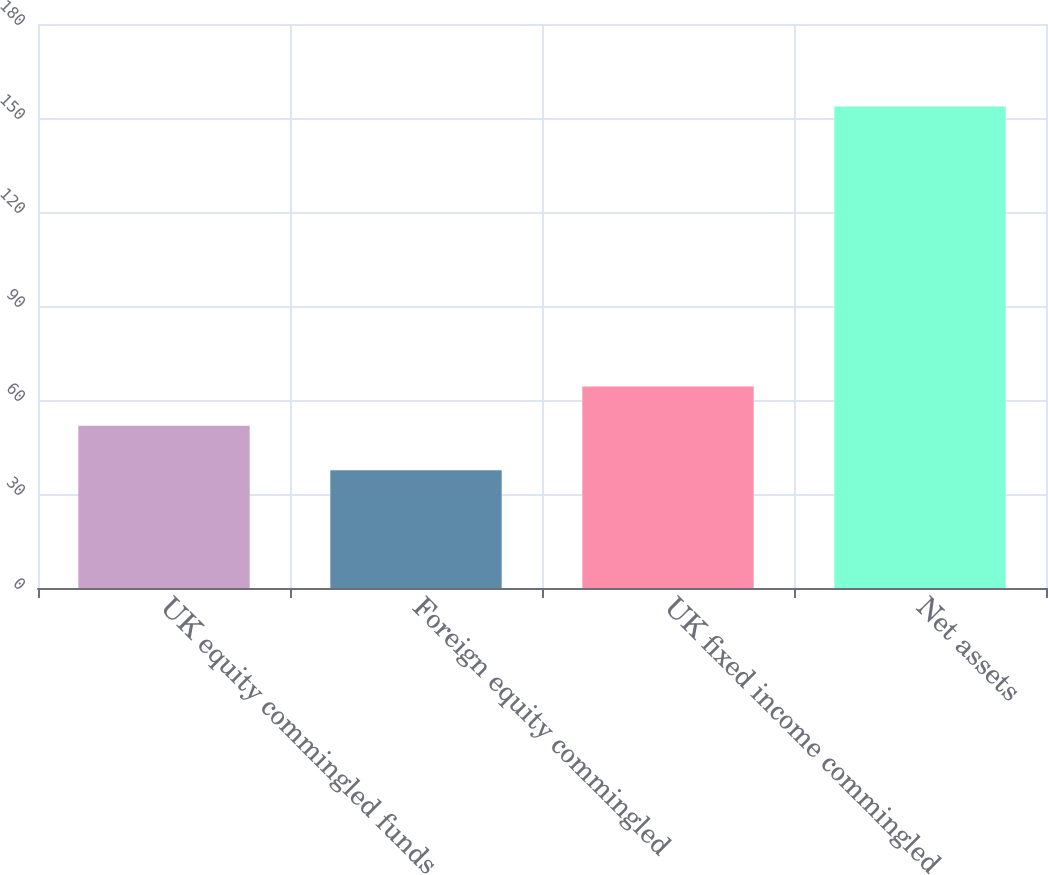Convert chart to OTSL. <chart><loc_0><loc_0><loc_500><loc_500><bar_chart><fcel>UK equity commingled funds<fcel>Foreign equity commingled<fcel>UK fixed income commingled<fcel>Net assets<nl><fcel>51.8<fcel>37.6<fcel>64.3<fcel>153.7<nl></chart> 